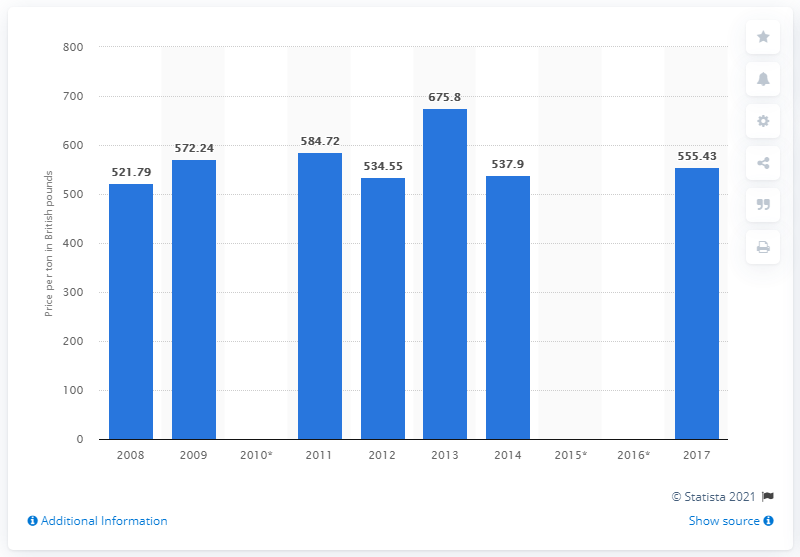Specify some key components in this picture. The last time bakers' yeast was manufactured in the UK was in 2008. 